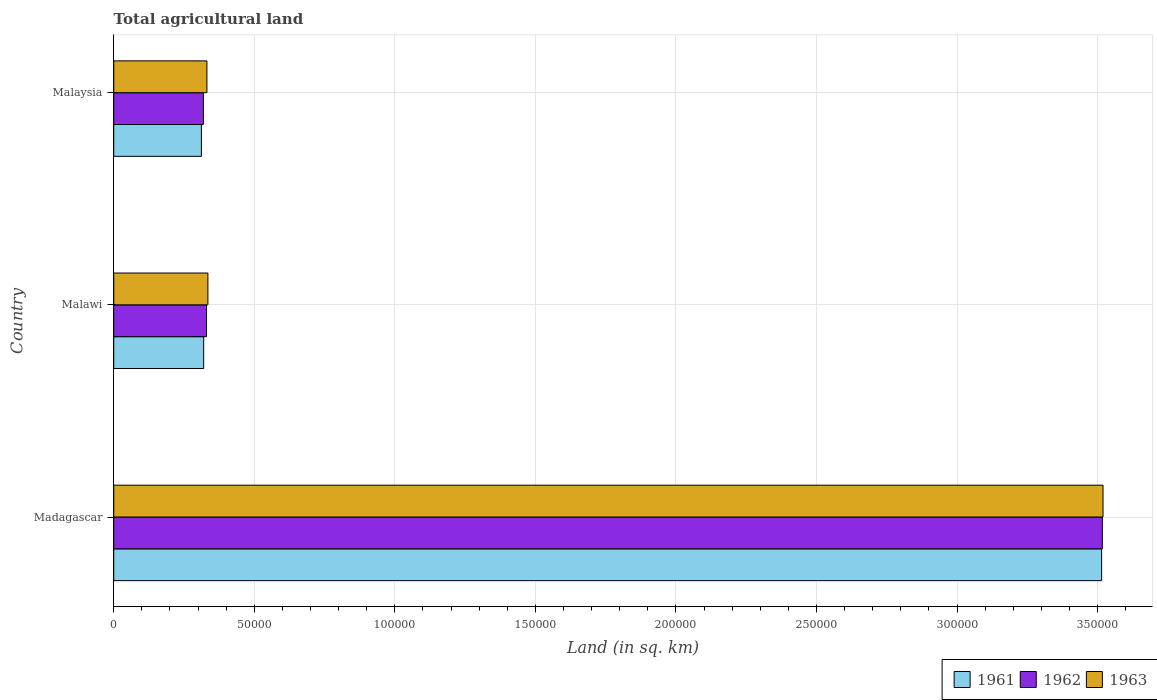How many different coloured bars are there?
Give a very brief answer. 3. How many groups of bars are there?
Keep it short and to the point. 3. How many bars are there on the 3rd tick from the top?
Your answer should be very brief. 3. How many bars are there on the 2nd tick from the bottom?
Offer a terse response. 3. What is the label of the 1st group of bars from the top?
Offer a very short reply. Malaysia. What is the total agricultural land in 1962 in Madagascar?
Offer a very short reply. 3.52e+05. Across all countries, what is the maximum total agricultural land in 1962?
Ensure brevity in your answer.  3.52e+05. Across all countries, what is the minimum total agricultural land in 1962?
Your answer should be very brief. 3.19e+04. In which country was the total agricultural land in 1962 maximum?
Provide a short and direct response. Madagascar. In which country was the total agricultural land in 1963 minimum?
Provide a succinct answer. Malaysia. What is the total total agricultural land in 1961 in the graph?
Your answer should be very brief. 4.15e+05. What is the difference between the total agricultural land in 1962 in Madagascar and that in Malaysia?
Your answer should be very brief. 3.20e+05. What is the difference between the total agricultural land in 1961 in Malaysia and the total agricultural land in 1962 in Madagascar?
Ensure brevity in your answer.  -3.21e+05. What is the average total agricultural land in 1963 per country?
Provide a succinct answer. 1.40e+05. What is the ratio of the total agricultural land in 1961 in Malawi to that in Malaysia?
Your response must be concise. 1.03. What is the difference between the highest and the second highest total agricultural land in 1961?
Your response must be concise. 3.19e+05. What is the difference between the highest and the lowest total agricultural land in 1961?
Offer a terse response. 3.20e+05. Is the sum of the total agricultural land in 1962 in Madagascar and Malawi greater than the maximum total agricultural land in 1963 across all countries?
Keep it short and to the point. Yes. What does the 1st bar from the bottom in Malawi represents?
Ensure brevity in your answer.  1961. Is it the case that in every country, the sum of the total agricultural land in 1962 and total agricultural land in 1963 is greater than the total agricultural land in 1961?
Ensure brevity in your answer.  Yes. How many countries are there in the graph?
Your answer should be compact. 3. Does the graph contain any zero values?
Your answer should be compact. No. Does the graph contain grids?
Offer a terse response. Yes. Where does the legend appear in the graph?
Ensure brevity in your answer.  Bottom right. How many legend labels are there?
Make the answer very short. 3. What is the title of the graph?
Give a very brief answer. Total agricultural land. Does "1986" appear as one of the legend labels in the graph?
Provide a succinct answer. No. What is the label or title of the X-axis?
Ensure brevity in your answer.  Land (in sq. km). What is the label or title of the Y-axis?
Offer a terse response. Country. What is the Land (in sq. km) in 1961 in Madagascar?
Offer a very short reply. 3.51e+05. What is the Land (in sq. km) in 1962 in Madagascar?
Provide a succinct answer. 3.52e+05. What is the Land (in sq. km) in 1963 in Madagascar?
Keep it short and to the point. 3.52e+05. What is the Land (in sq. km) in 1961 in Malawi?
Provide a short and direct response. 3.20e+04. What is the Land (in sq. km) in 1962 in Malawi?
Offer a terse response. 3.30e+04. What is the Land (in sq. km) in 1963 in Malawi?
Make the answer very short. 3.35e+04. What is the Land (in sq. km) in 1961 in Malaysia?
Make the answer very short. 3.12e+04. What is the Land (in sq. km) of 1962 in Malaysia?
Ensure brevity in your answer.  3.19e+04. What is the Land (in sq. km) in 1963 in Malaysia?
Your response must be concise. 3.31e+04. Across all countries, what is the maximum Land (in sq. km) of 1961?
Give a very brief answer. 3.51e+05. Across all countries, what is the maximum Land (in sq. km) of 1962?
Your response must be concise. 3.52e+05. Across all countries, what is the maximum Land (in sq. km) in 1963?
Your answer should be very brief. 3.52e+05. Across all countries, what is the minimum Land (in sq. km) of 1961?
Make the answer very short. 3.12e+04. Across all countries, what is the minimum Land (in sq. km) in 1962?
Make the answer very short. 3.19e+04. Across all countries, what is the minimum Land (in sq. km) of 1963?
Your answer should be very brief. 3.31e+04. What is the total Land (in sq. km) of 1961 in the graph?
Offer a terse response. 4.15e+05. What is the total Land (in sq. km) in 1962 in the graph?
Give a very brief answer. 4.17e+05. What is the total Land (in sq. km) in 1963 in the graph?
Ensure brevity in your answer.  4.19e+05. What is the difference between the Land (in sq. km) in 1961 in Madagascar and that in Malawi?
Ensure brevity in your answer.  3.19e+05. What is the difference between the Land (in sq. km) of 1962 in Madagascar and that in Malawi?
Your answer should be very brief. 3.19e+05. What is the difference between the Land (in sq. km) of 1963 in Madagascar and that in Malawi?
Provide a short and direct response. 3.18e+05. What is the difference between the Land (in sq. km) in 1961 in Madagascar and that in Malaysia?
Keep it short and to the point. 3.20e+05. What is the difference between the Land (in sq. km) in 1962 in Madagascar and that in Malaysia?
Give a very brief answer. 3.20e+05. What is the difference between the Land (in sq. km) in 1963 in Madagascar and that in Malaysia?
Keep it short and to the point. 3.19e+05. What is the difference between the Land (in sq. km) in 1961 in Malawi and that in Malaysia?
Offer a very short reply. 815. What is the difference between the Land (in sq. km) of 1962 in Malawi and that in Malaysia?
Give a very brief answer. 1122. What is the difference between the Land (in sq. km) in 1963 in Malawi and that in Malaysia?
Offer a very short reply. 358. What is the difference between the Land (in sq. km) of 1961 in Madagascar and the Land (in sq. km) of 1962 in Malawi?
Provide a succinct answer. 3.18e+05. What is the difference between the Land (in sq. km) in 1961 in Madagascar and the Land (in sq. km) in 1963 in Malawi?
Provide a succinct answer. 3.18e+05. What is the difference between the Land (in sq. km) in 1962 in Madagascar and the Land (in sq. km) in 1963 in Malawi?
Provide a succinct answer. 3.18e+05. What is the difference between the Land (in sq. km) of 1961 in Madagascar and the Land (in sq. km) of 1962 in Malaysia?
Provide a short and direct response. 3.20e+05. What is the difference between the Land (in sq. km) in 1961 in Madagascar and the Land (in sq. km) in 1963 in Malaysia?
Your answer should be compact. 3.18e+05. What is the difference between the Land (in sq. km) of 1962 in Madagascar and the Land (in sq. km) of 1963 in Malaysia?
Provide a succinct answer. 3.19e+05. What is the difference between the Land (in sq. km) of 1961 in Malawi and the Land (in sq. km) of 1962 in Malaysia?
Provide a succinct answer. 122. What is the difference between the Land (in sq. km) of 1961 in Malawi and the Land (in sq. km) of 1963 in Malaysia?
Offer a very short reply. -1142. What is the difference between the Land (in sq. km) in 1962 in Malawi and the Land (in sq. km) in 1963 in Malaysia?
Offer a very short reply. -142. What is the average Land (in sq. km) in 1961 per country?
Offer a terse response. 1.38e+05. What is the average Land (in sq. km) of 1962 per country?
Make the answer very short. 1.39e+05. What is the average Land (in sq. km) in 1963 per country?
Offer a terse response. 1.40e+05. What is the difference between the Land (in sq. km) in 1961 and Land (in sq. km) in 1962 in Madagascar?
Offer a terse response. -250. What is the difference between the Land (in sq. km) in 1961 and Land (in sq. km) in 1963 in Madagascar?
Make the answer very short. -500. What is the difference between the Land (in sq. km) of 1962 and Land (in sq. km) of 1963 in Madagascar?
Your response must be concise. -250. What is the difference between the Land (in sq. km) of 1961 and Land (in sq. km) of 1962 in Malawi?
Keep it short and to the point. -1000. What is the difference between the Land (in sq. km) of 1961 and Land (in sq. km) of 1963 in Malawi?
Provide a succinct answer. -1500. What is the difference between the Land (in sq. km) in 1962 and Land (in sq. km) in 1963 in Malawi?
Make the answer very short. -500. What is the difference between the Land (in sq. km) in 1961 and Land (in sq. km) in 1962 in Malaysia?
Your answer should be compact. -693. What is the difference between the Land (in sq. km) of 1961 and Land (in sq. km) of 1963 in Malaysia?
Provide a succinct answer. -1957. What is the difference between the Land (in sq. km) of 1962 and Land (in sq. km) of 1963 in Malaysia?
Make the answer very short. -1264. What is the ratio of the Land (in sq. km) in 1961 in Madagascar to that in Malawi?
Offer a very short reply. 10.98. What is the ratio of the Land (in sq. km) of 1962 in Madagascar to that in Malawi?
Your response must be concise. 10.66. What is the ratio of the Land (in sq. km) of 1963 in Madagascar to that in Malawi?
Offer a terse response. 10.51. What is the ratio of the Land (in sq. km) in 1961 in Madagascar to that in Malaysia?
Ensure brevity in your answer.  11.27. What is the ratio of the Land (in sq. km) of 1962 in Madagascar to that in Malaysia?
Keep it short and to the point. 11.03. What is the ratio of the Land (in sq. km) of 1963 in Madagascar to that in Malaysia?
Your response must be concise. 10.62. What is the ratio of the Land (in sq. km) in 1961 in Malawi to that in Malaysia?
Your response must be concise. 1.03. What is the ratio of the Land (in sq. km) in 1962 in Malawi to that in Malaysia?
Offer a very short reply. 1.04. What is the ratio of the Land (in sq. km) of 1963 in Malawi to that in Malaysia?
Provide a succinct answer. 1.01. What is the difference between the highest and the second highest Land (in sq. km) in 1961?
Offer a terse response. 3.19e+05. What is the difference between the highest and the second highest Land (in sq. km) in 1962?
Provide a short and direct response. 3.19e+05. What is the difference between the highest and the second highest Land (in sq. km) in 1963?
Your answer should be very brief. 3.18e+05. What is the difference between the highest and the lowest Land (in sq. km) in 1961?
Provide a short and direct response. 3.20e+05. What is the difference between the highest and the lowest Land (in sq. km) of 1962?
Your response must be concise. 3.20e+05. What is the difference between the highest and the lowest Land (in sq. km) in 1963?
Offer a very short reply. 3.19e+05. 